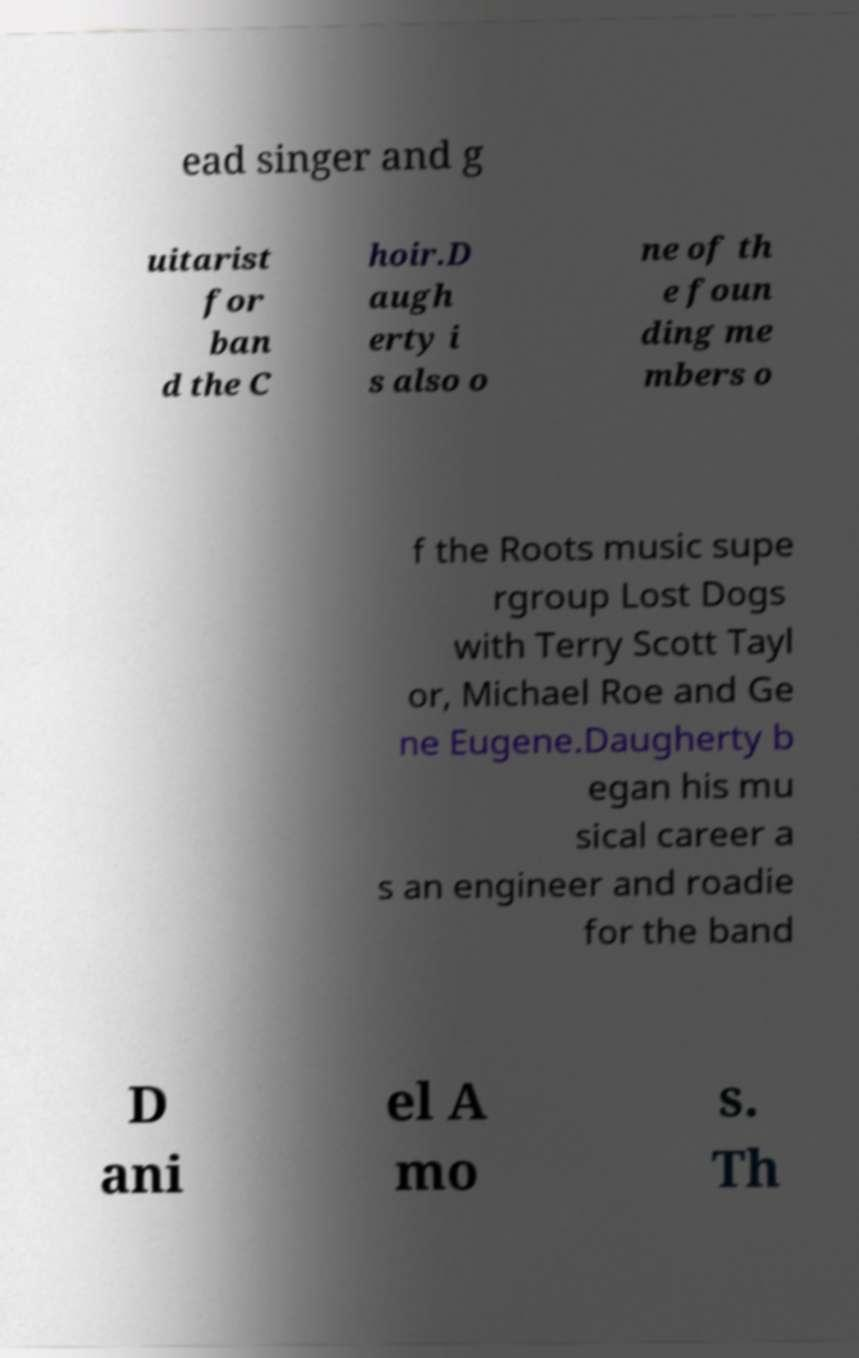For documentation purposes, I need the text within this image transcribed. Could you provide that? ead singer and g uitarist for ban d the C hoir.D augh erty i s also o ne of th e foun ding me mbers o f the Roots music supe rgroup Lost Dogs with Terry Scott Tayl or, Michael Roe and Ge ne Eugene.Daugherty b egan his mu sical career a s an engineer and roadie for the band D ani el A mo s. Th 